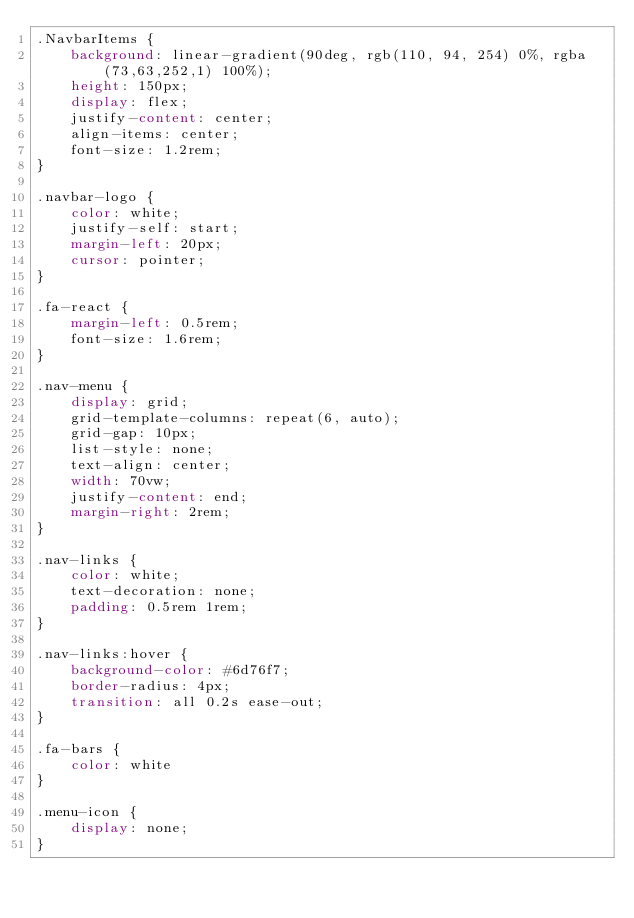Convert code to text. <code><loc_0><loc_0><loc_500><loc_500><_CSS_>.NavbarItems {
    background: linear-gradient(90deg, rgb(110, 94, 254) 0%, rgba(73,63,252,1) 100%);
    height: 150px;
    display: flex;
    justify-content: center;
    align-items: center;
    font-size: 1.2rem;
}

.navbar-logo {
    color: white;
    justify-self: start;
    margin-left: 20px;
    cursor: pointer;
}

.fa-react {
    margin-left: 0.5rem;
    font-size: 1.6rem;
}

.nav-menu {
    display: grid;
    grid-template-columns: repeat(6, auto);
    grid-gap: 10px;
    list-style: none;
    text-align: center;
    width: 70vw;
    justify-content: end;
    margin-right: 2rem;
}

.nav-links {
    color: white;
    text-decoration: none;
    padding: 0.5rem 1rem;
}

.nav-links:hover {
    background-color: #6d76f7;
    border-radius: 4px;
    transition: all 0.2s ease-out;
}

.fa-bars {
    color: white
}

.menu-icon {
    display: none;
}
</code> 